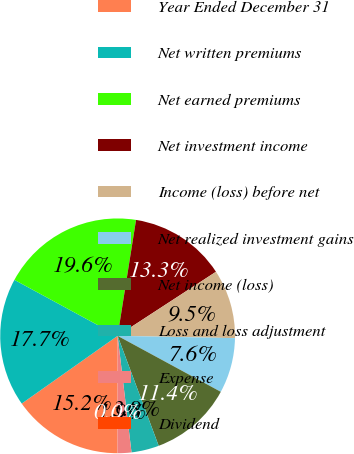Convert chart. <chart><loc_0><loc_0><loc_500><loc_500><pie_chart><fcel>Year Ended December 31<fcel>Net written premiums<fcel>Net earned premiums<fcel>Net investment income<fcel>Income (loss) before net<fcel>Net realized investment gains<fcel>Net income (loss)<fcel>Loss and loss adjustment<fcel>Expense<fcel>Dividend<nl><fcel>15.2%<fcel>17.7%<fcel>19.6%<fcel>13.3%<fcel>9.5%<fcel>7.6%<fcel>11.4%<fcel>3.8%<fcel>1.9%<fcel>0.0%<nl></chart> 